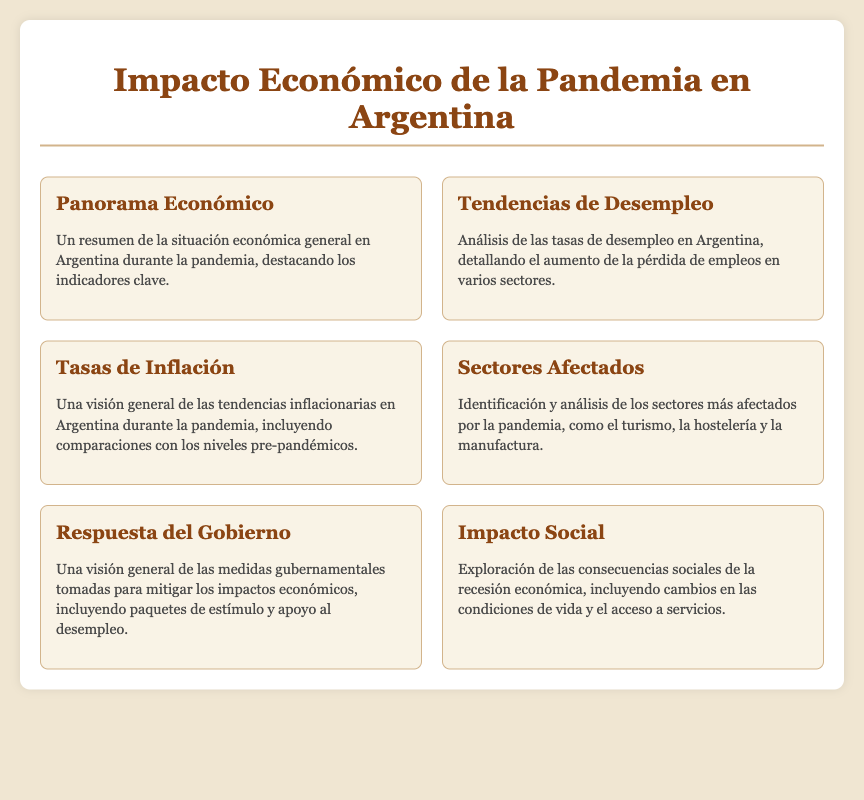¿Qué se analiza en la sección "Tendencias de Desempleo"? La sección "Tendencias de Desempleo" analiza las tasas de desempleo en Argentina y el aumento de la pérdida de empleos en varios sectores.
Answer: Tasas de desempleo ¿Cuáles son algunos de los sectores identificados como más afectados? La sección "Sectores Afectados" identifica y analiza sectores como el turismo, la hostelería y la manufactura.
Answer: Turismo, hostelería, manufactura ¿Qué tipo de respuestas se mencionan en la sección "Respuesta del Gobierno"? La sección "Respuesta del Gobierno" proporciona una visión general de las medidas gubernamentales para mitigar impactos económicos, incluyendo paquetes de estímulo y apoyo al desempleo.
Answer: Paquetes de estímulo ¿Qué se destaca en el "Panorama Económico"? En el "Panorama Económico" se resumen los indicadores clave de la situación económica general en Argentina durante la pandemia.
Answer: Indicadores clave ¿Cómo se describe la visión general de la inflación en Argentina? La sección "Tasas de Inflación" ofrece una visión general de las tendencias inflacionarias en Argentina durante la pandemia, con comparaciones pre-pandémicas.
Answer: Tendencias inflacionarias 